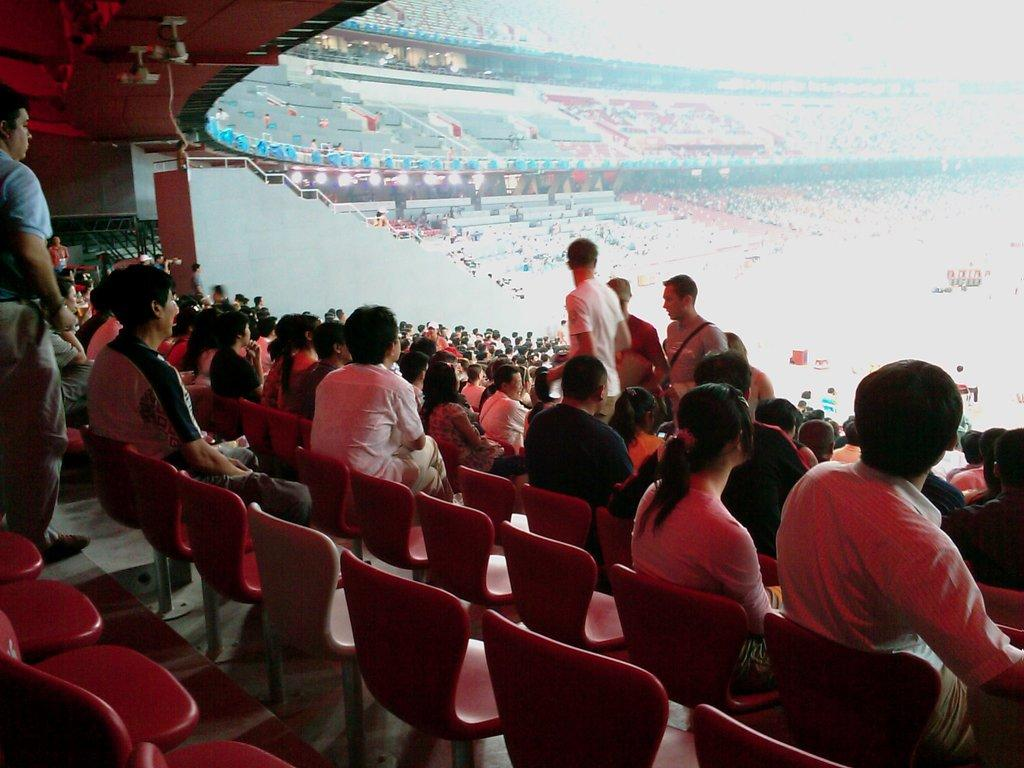How many people are in the image? There is a group of people in the image. What are some of the people in the image doing? Some people are standing, and some people are sitting on chairs. What can be seen in the background of the image? There is a stadium in the background of the image. What type of boats can be seen in the image? There are no boats present in the image. What type of office furniture can be seen in the image? There is no office furniture present in the image. 